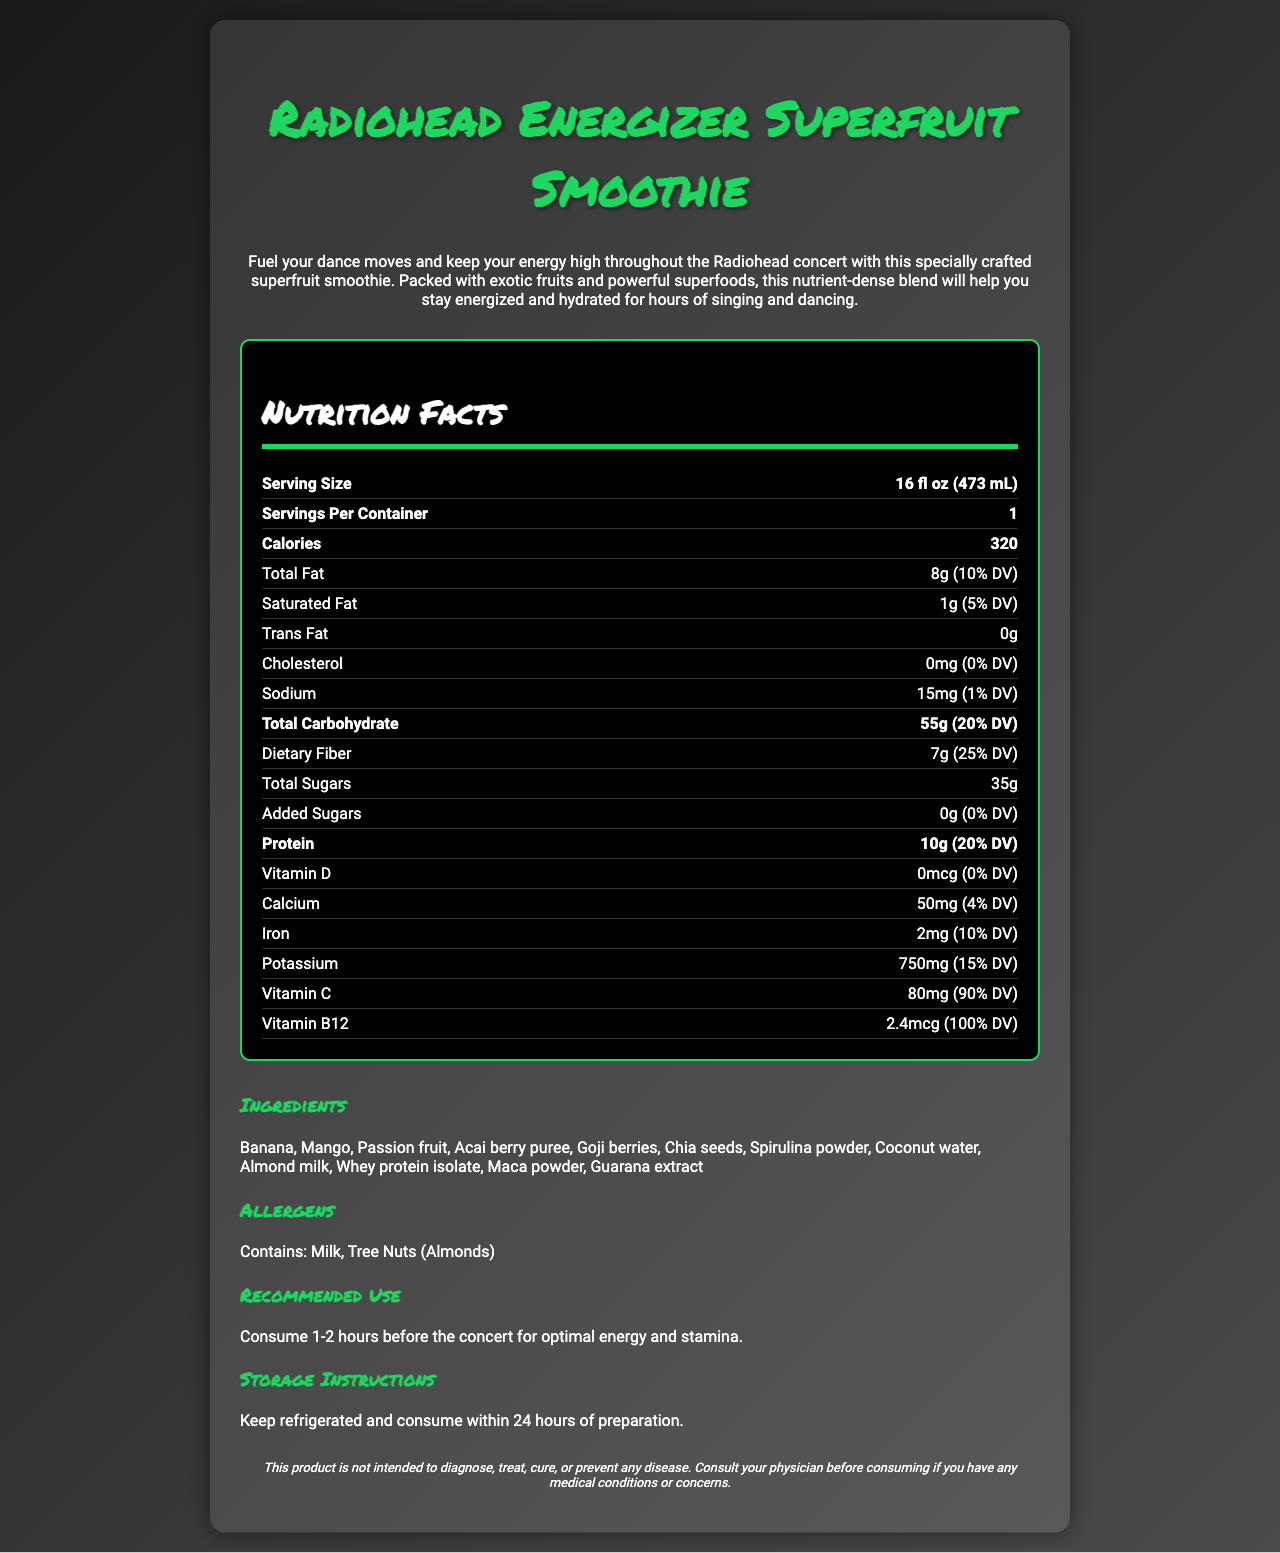what is the serving size? The serving size is listed directly under the "Nutrition Facts" section as "Serving Size: 16 fl oz (473 mL)."
Answer: 16 fl oz (473 mL) how many calories are in one serving? The number of calories per serving is displayed in the bold section as "Calories: 320."
Answer: 320 what is the main source of protein in the smoothie? The main source of protein in the smoothie is listed in the ingredients section as "Whey protein isolate."
Answer: Whey protein isolate how much vitamin c does the smoothie contain? The amount of Vitamin C is noted in the nutrition facts section as "Vitamin C: 80 mg (90% DV)."
Answer: 80 mg which superfood ingredients are included in the smoothie? These superfoods are listed in the ingredients section of the document.
Answer: Acai berry puree, Goji berries, Chia seeds, Spirulina powder, Maca powder, Guarana extract how many grams of dietary fiber are in one serving? The nutrition facts section shows "Dietary Fiber: 7 g (25% DV)."
Answer: 7 g what is the recommended use for the smoothie? This information is provided in the "Recommended Use" section.
Answer: Consume 1-2 hours before the concert for optimal energy and stamina. what are the allergens contained in the smoothie? The allergens are specified in the allergens section as "Contains: Milk, Tree Nuts (Almonds)."
Answer: Milk, Tree Nuts (Almonds) does the smoothie contain any trans fat? The nutrition facts section indicates "Trans Fat: 0 g."
Answer: No summarize the purpose of this smoothie. The product description explains that the smoothie is crafted to fuel dance moves and keep energy high throughout the concert with nutrient-dense exotic fruits and superfoods, promoting energy and hydration.
Answer: To provide high energy and hydration for a Radiohead concert. how much calcium does one serving provide? The nutrition facts section details the calcium content as "Calcium: 50 mg (4% DV)."
Answer: 50 mg (4% DV) which vitamin has the highest daily value percentage? A. Vitamin D B. Vitamin C C. Vitamin B12 D. Potassium The nutrition facts section shows Vitamin B12 at 100% DV, the highest among the listed vitamins and minerals.
Answer: C how much sodium is in the smoothie? The sodium content is shown in the nutrition facts as "Sodium: 15 mg (1% DV)."
Answer: 15 mg what type of nut is an allergen in this smoothie? A. Peanuts B. Walnuts C. Almonds The allergens section lists "Tree Nuts (Almonds)" specifically.
Answer: C is this product intended to prevent any disease? The disclaimer at the bottom of the document states, "This product is not intended to diagnose, treat, cure, or prevent any disease."
Answer: No can the exact preparation date of the smoothie be determined? The document does not give any details about the preparation date of the smoothie. The storage instructions only mention keeping it refrigerated and consuming within 24 hours of preparation.
Answer: Not enough information 